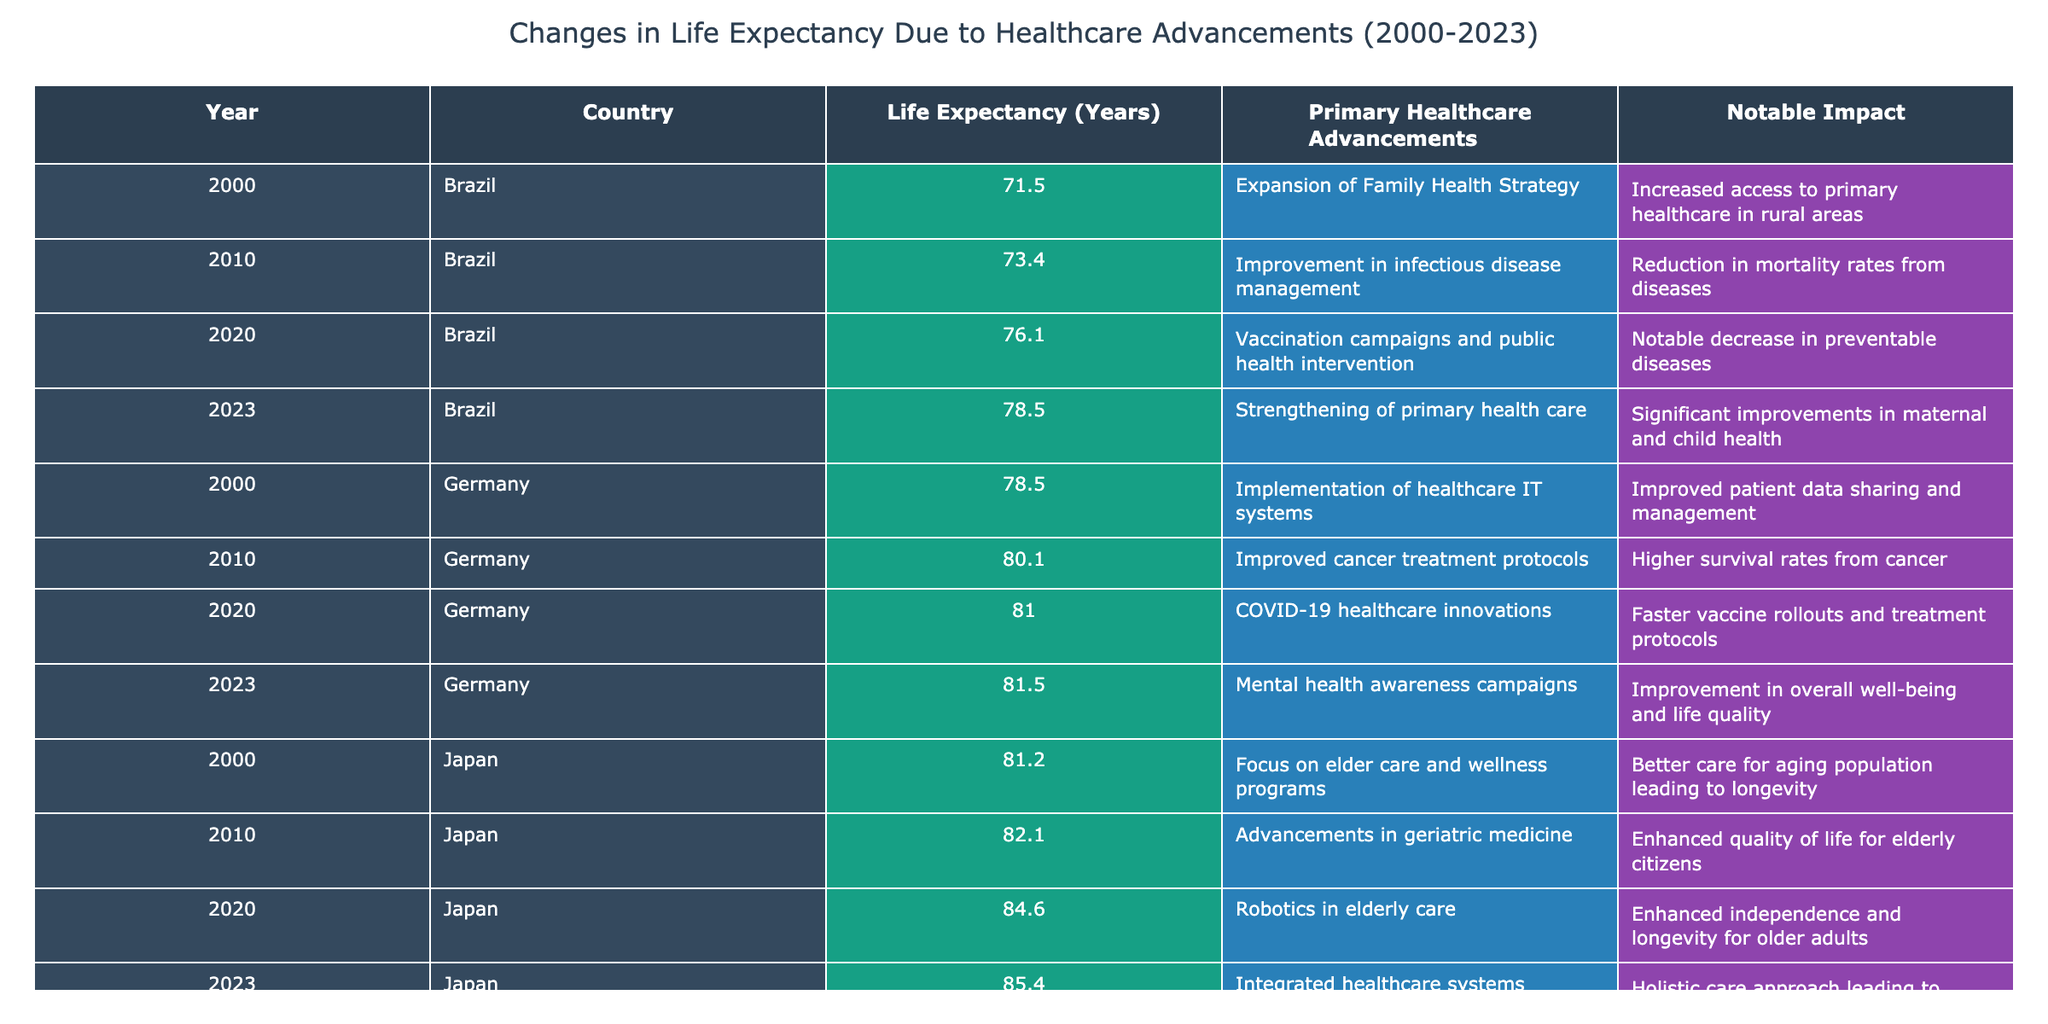What was the life expectancy in Japan in 2023? Looking at the table, under the "Year" 2023 and "Country" Japan, the life expectancy indicated is 85.4 years.
Answer: 85.4 years Which country had the greatest increase in life expectancy from 2000 to 2023? By comparing the life expectancy values across the two years for each country, the United States had a life expectancy of 76.8 years in 2000 and 79.3 years in 2023, an increase of 2.5 years. Japan went from 81.2 years to 85.4 years, an increase of 4.2 years. Hence, Japan had the greatest increase.
Answer: Japan Did Germany experience a decrease in life expectancy between 2010 and 2020? Checking the values for Germany, the life expectancy in 2010 was 80.1 years and in 2020 it decreased to 81.0 years. Since 81.0 years is greater, Germany did not experience a decrease.
Answer: No What is the average life expectancy for Brazil between 2000 and 2023? To find the average for Brazil, the life expectancies listed are 71.5 (2000), 73.4 (2010), 76.1 (2020), and 78.5 (2023). Summing these gives 299.5 years. There are four data points, so the average is 299.5 / 4 = 74.875 years.
Answer: 74.875 years Was the introduction of the Affordable Care Act in the United States significant enough to increase its life expectancy within the time frame? In 2010, after the introduction of the Affordable Care Act, life expectancy increased from 76.8 years in 2000 to 78.7 years in 2010, indicating a positive impact. Additionally, life expectancy continued to increase to 79.3 years in 2023, underlining a consistent upward trend due to advancements in healthcare.
Answer: Yes 